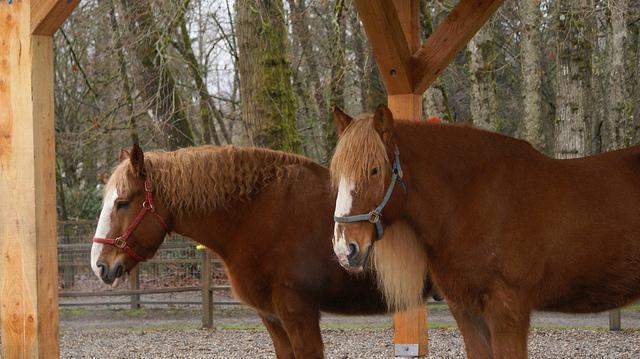How many horses can you see?
Give a very brief answer. 2. 